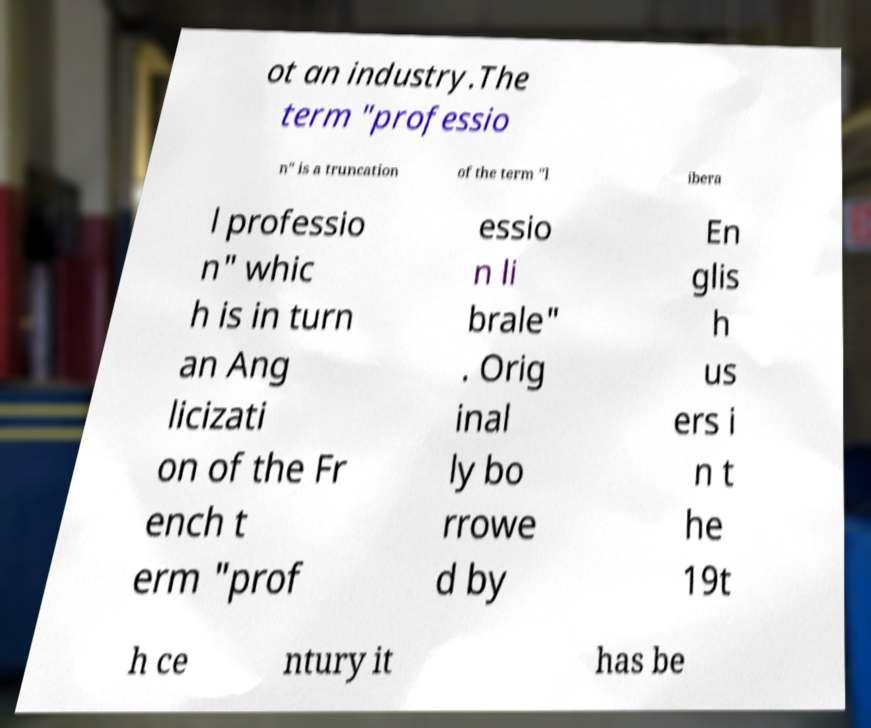Could you assist in decoding the text presented in this image and type it out clearly? ot an industry.The term "professio n" is a truncation of the term "l ibera l professio n" whic h is in turn an Ang licizati on of the Fr ench t erm "prof essio n li brale" . Orig inal ly bo rrowe d by En glis h us ers i n t he 19t h ce ntury it has be 